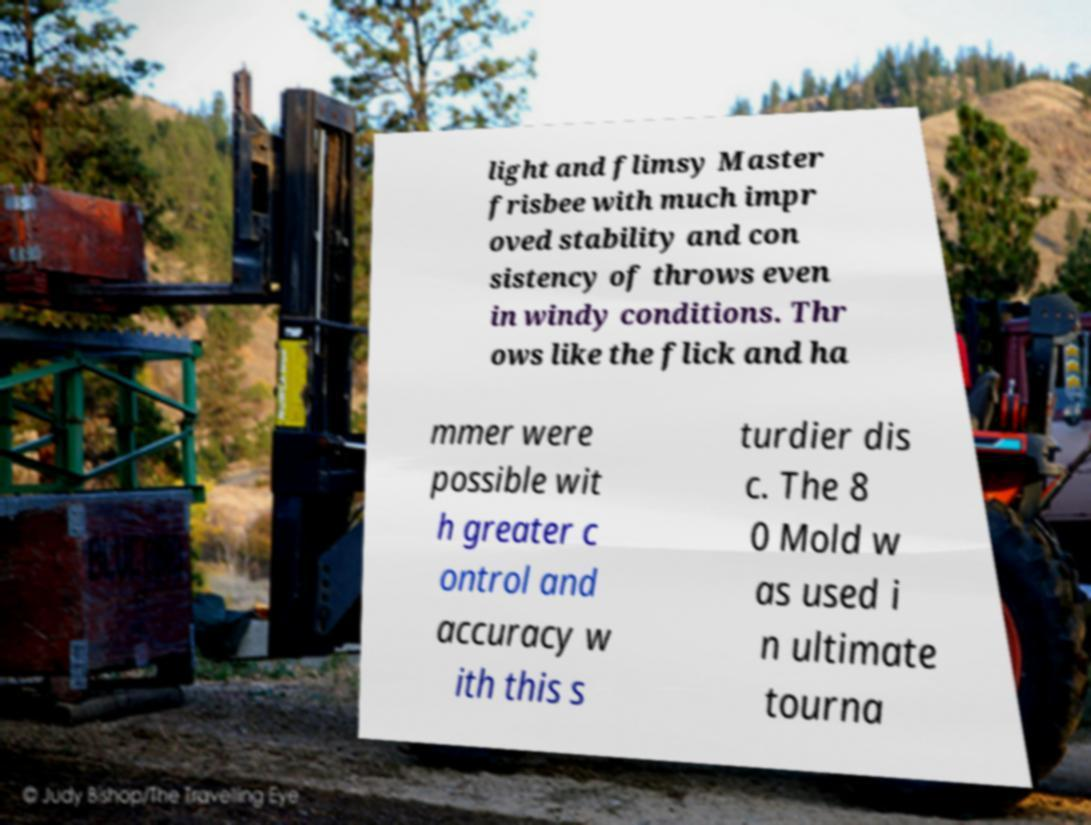Could you assist in decoding the text presented in this image and type it out clearly? light and flimsy Master frisbee with much impr oved stability and con sistency of throws even in windy conditions. Thr ows like the flick and ha mmer were possible wit h greater c ontrol and accuracy w ith this s turdier dis c. The 8 0 Mold w as used i n ultimate tourna 